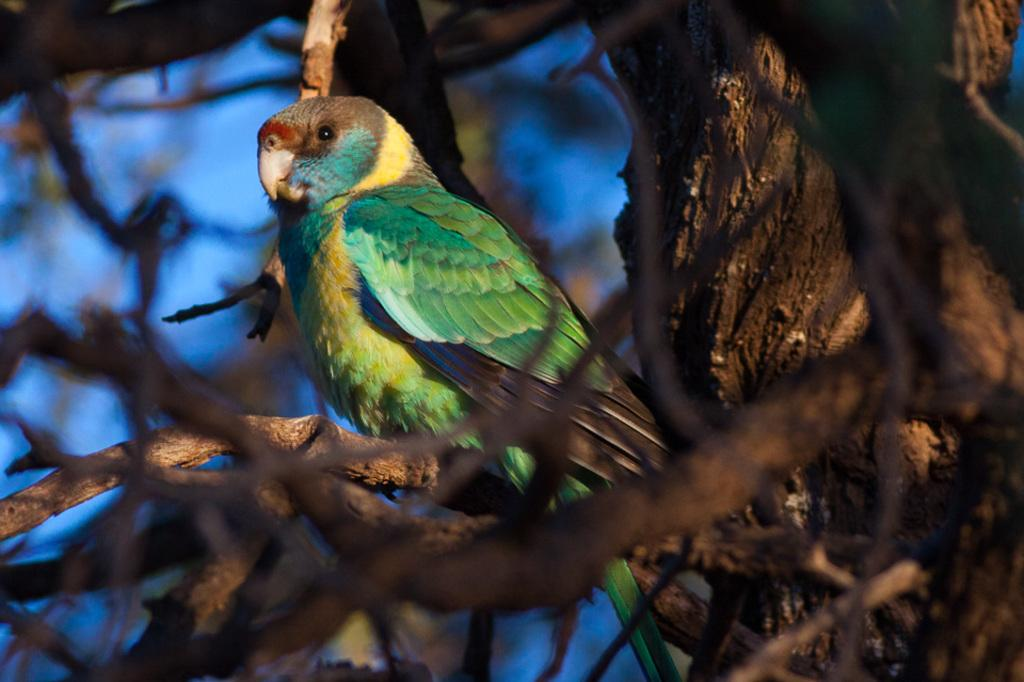What type of animal is in the image? There is a parrot in the image. Where is the parrot located? The parrot is sitting on a branch of a tree. What color is the parrot? The parrot is in green color. What type of lace is the parrot using to decorate the party in the image? There is no lace or party present in the image; it features a parrot sitting on a tree branch. 